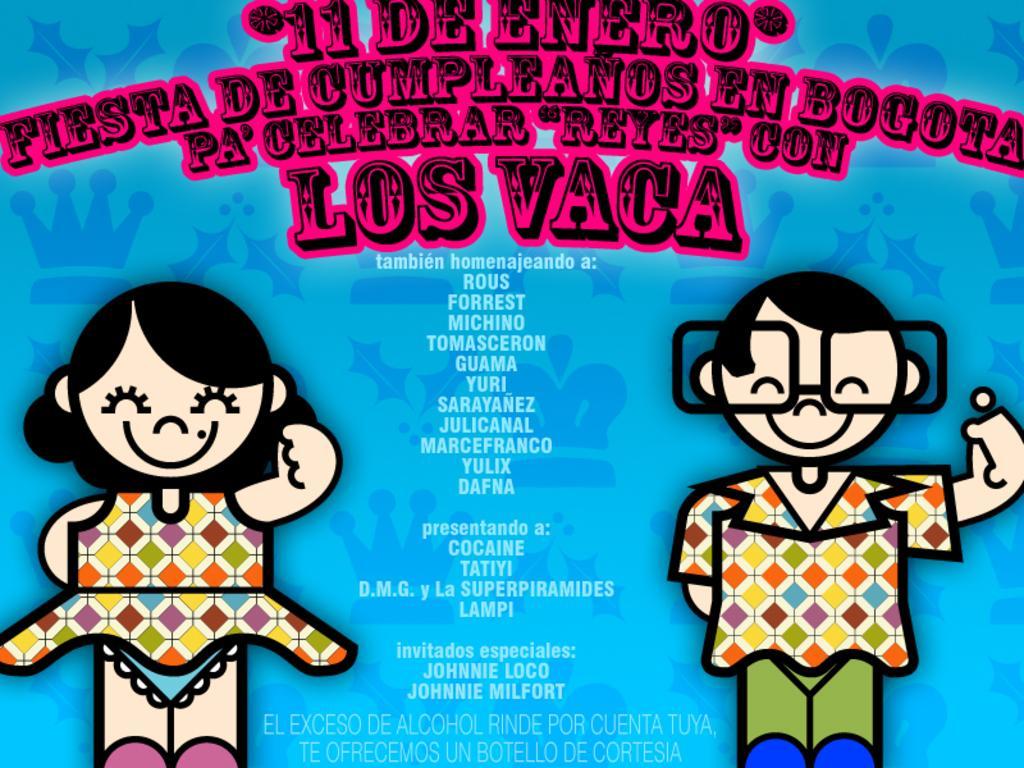In one or two sentences, can you explain what this image depicts? In this picture I can see a poster with some text and I can see couple of cartoon images. 